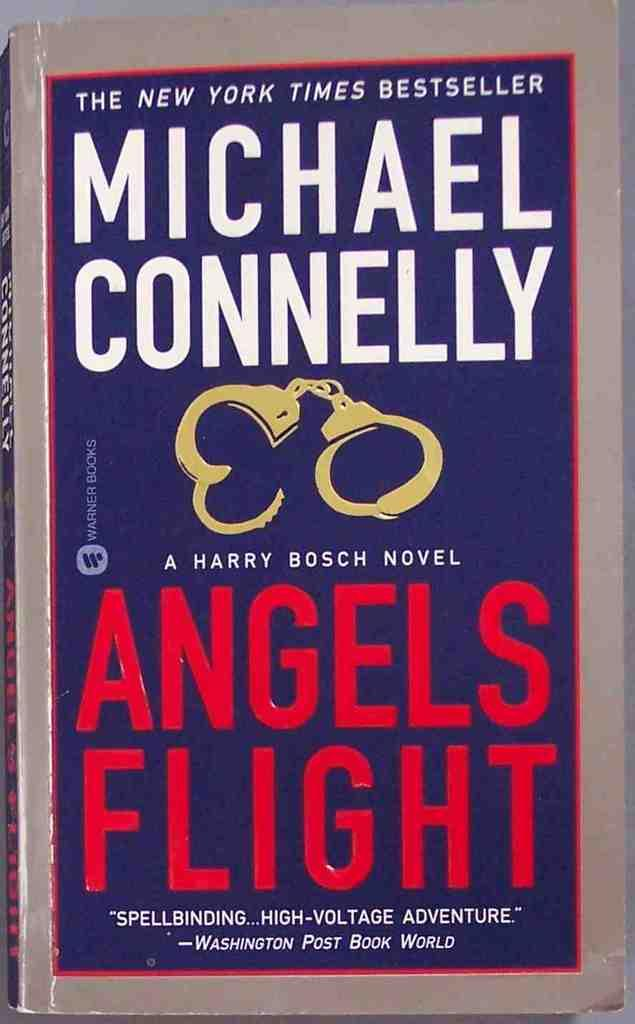Provide a one-sentence caption for the provided image. a book titled Angels Flight by Michael Connelly. 